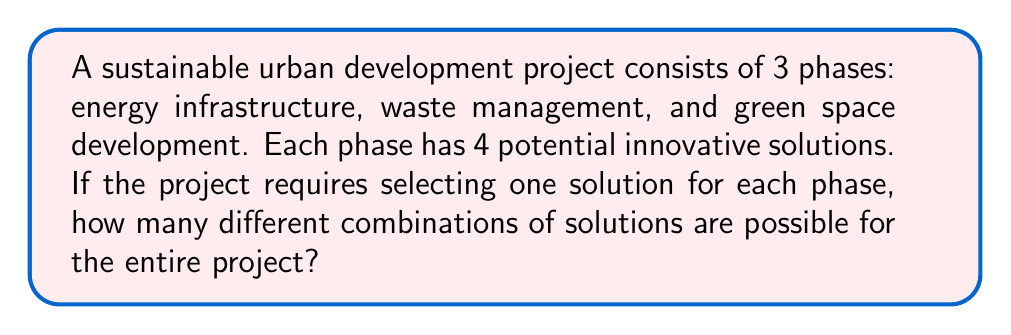Solve this math problem. Let's approach this step-by-step:

1) We have 3 phases in the project:
   - Energy infrastructure
   - Waste management
   - Green space development

2) For each phase, there are 4 potential innovative solutions.

3) We need to select one solution for each phase.

4) This scenario can be modeled using the multiplication principle of counting.

5) The multiplication principle states that if we have a sequence of $n$ choices, where:
   - the first choice has $m_1$ options
   - the second choice has $m_2$ options
   - ...
   - the $n$-th choice has $m_n$ options

   Then the total number of possible outcomes is:

   $$ m_1 \times m_2 \times ... \times m_n $$

6) In our case:
   - For the first phase (energy infrastructure), we have 4 choices
   - For the second phase (waste management), we have 4 choices
   - For the third phase (green space development), we have 4 choices

7) Therefore, the total number of possible combinations is:

   $$ 4 \times 4 \times 4 = 4^3 = 64 $$

Thus, there are 64 different possible combinations of solutions for the entire project.
Answer: 64 